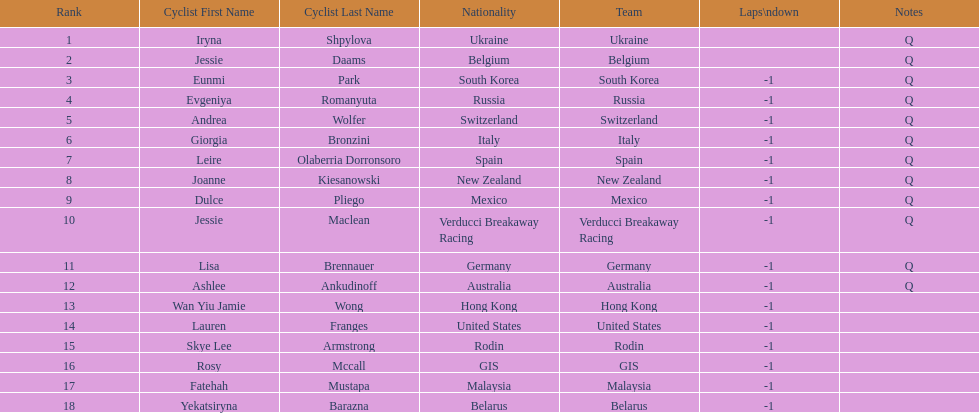Who was the competitor that finished above jessie maclean? Dulce Pliego. 